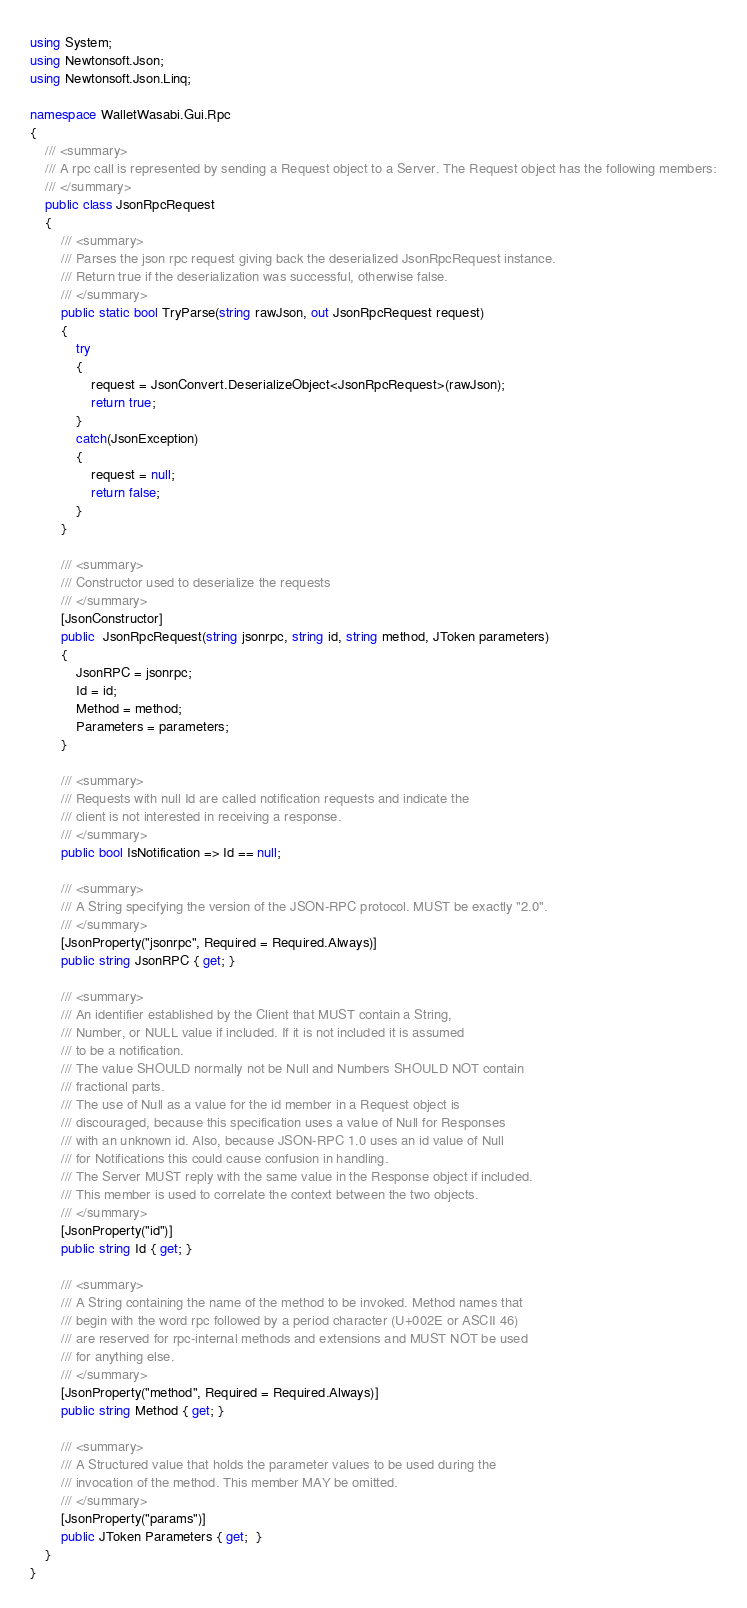<code> <loc_0><loc_0><loc_500><loc_500><_C#_>using System;
using Newtonsoft.Json;
using Newtonsoft.Json.Linq;

namespace WalletWasabi.Gui.Rpc
{
	/// <summary>
	/// A rpc call is represented by sending a Request object to a Server. The Request object has the following members:
	/// </summary>
	public class JsonRpcRequest
	{
		/// <summary>
		/// Parses the json rpc request giving back the deserialized JsonRpcRequest instance.
		/// Return true if the deserialization was successful, otherwise false.
		/// </summary>
		public static bool TryParse(string rawJson, out JsonRpcRequest request)
		{
			try
			{
				request = JsonConvert.DeserializeObject<JsonRpcRequest>(rawJson);
				return true;
			}
			catch(JsonException)
			{
				request = null;
				return false;
			}
		}

		/// <summary>
		/// Constructor used to deserialize the requests
		/// </summary>
		[JsonConstructor]
		public  JsonRpcRequest(string jsonrpc, string id, string method, JToken parameters)
		{
			JsonRPC = jsonrpc;
			Id = id;
			Method = method;
			Parameters = parameters;
		}

		/// <summary>
		/// Requests with null Id are called notification requests and indicate the
		/// client is not interested in receiving a response.
		/// </summary>
		public bool IsNotification => Id == null;

		/// <summary>
		/// A String specifying the version of the JSON-RPC protocol. MUST be exactly "2.0".
		/// </summary>
		[JsonProperty("jsonrpc", Required = Required.Always)]
		public string JsonRPC { get; }

		/// <summary>
		/// An identifier established by the Client that MUST contain a String, 
		/// Number, or NULL value if included. If it is not included it is assumed
		/// to be a notification.
		/// The value SHOULD normally not be Null and Numbers SHOULD NOT contain 
		/// fractional parts.
		/// The use of Null as a value for the id member in a Request object is 
		/// discouraged, because this specification uses a value of Null for Responses
		/// with an unknown id. Also, because JSON-RPC 1.0 uses an id value of Null 
		/// for Notifications this could cause confusion in handling.
		/// The Server MUST reply with the same value in the Response object if included.
		/// This member is used to correlate the context between the two objects.
		/// </summary>
		[JsonProperty("id")]
		public string Id { get; }

		/// <summary>
		/// A String containing the name of the method to be invoked. Method names that
		/// begin with the word rpc followed by a period character (U+002E or ASCII 46)
		/// are reserved for rpc-internal methods and extensions and MUST NOT be used 
		/// for anything else.
		/// </summary>
		[JsonProperty("method", Required = Required.Always)]
		public string Method { get; }

		/// <summary>
		/// A Structured value that holds the parameter values to be used during the
		/// invocation of the method. This member MAY be omitted.
		/// </summary>
		[JsonProperty("params")]
		public JToken Parameters { get;  }
	}
}
</code> 